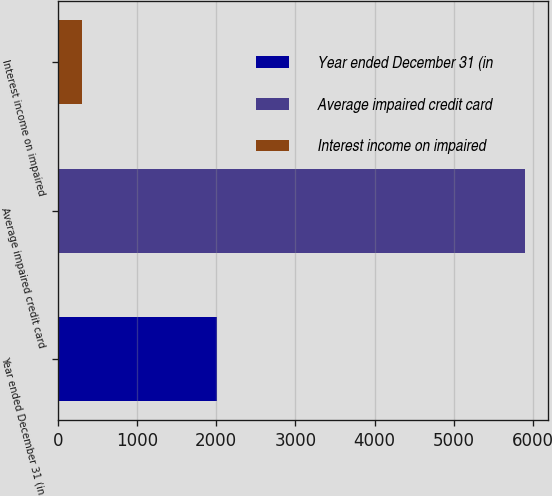<chart> <loc_0><loc_0><loc_500><loc_500><bar_chart><fcel>Year ended December 31 (in<fcel>Average impaired credit card<fcel>Interest income on impaired<nl><fcel>2012<fcel>5893<fcel>308<nl></chart> 